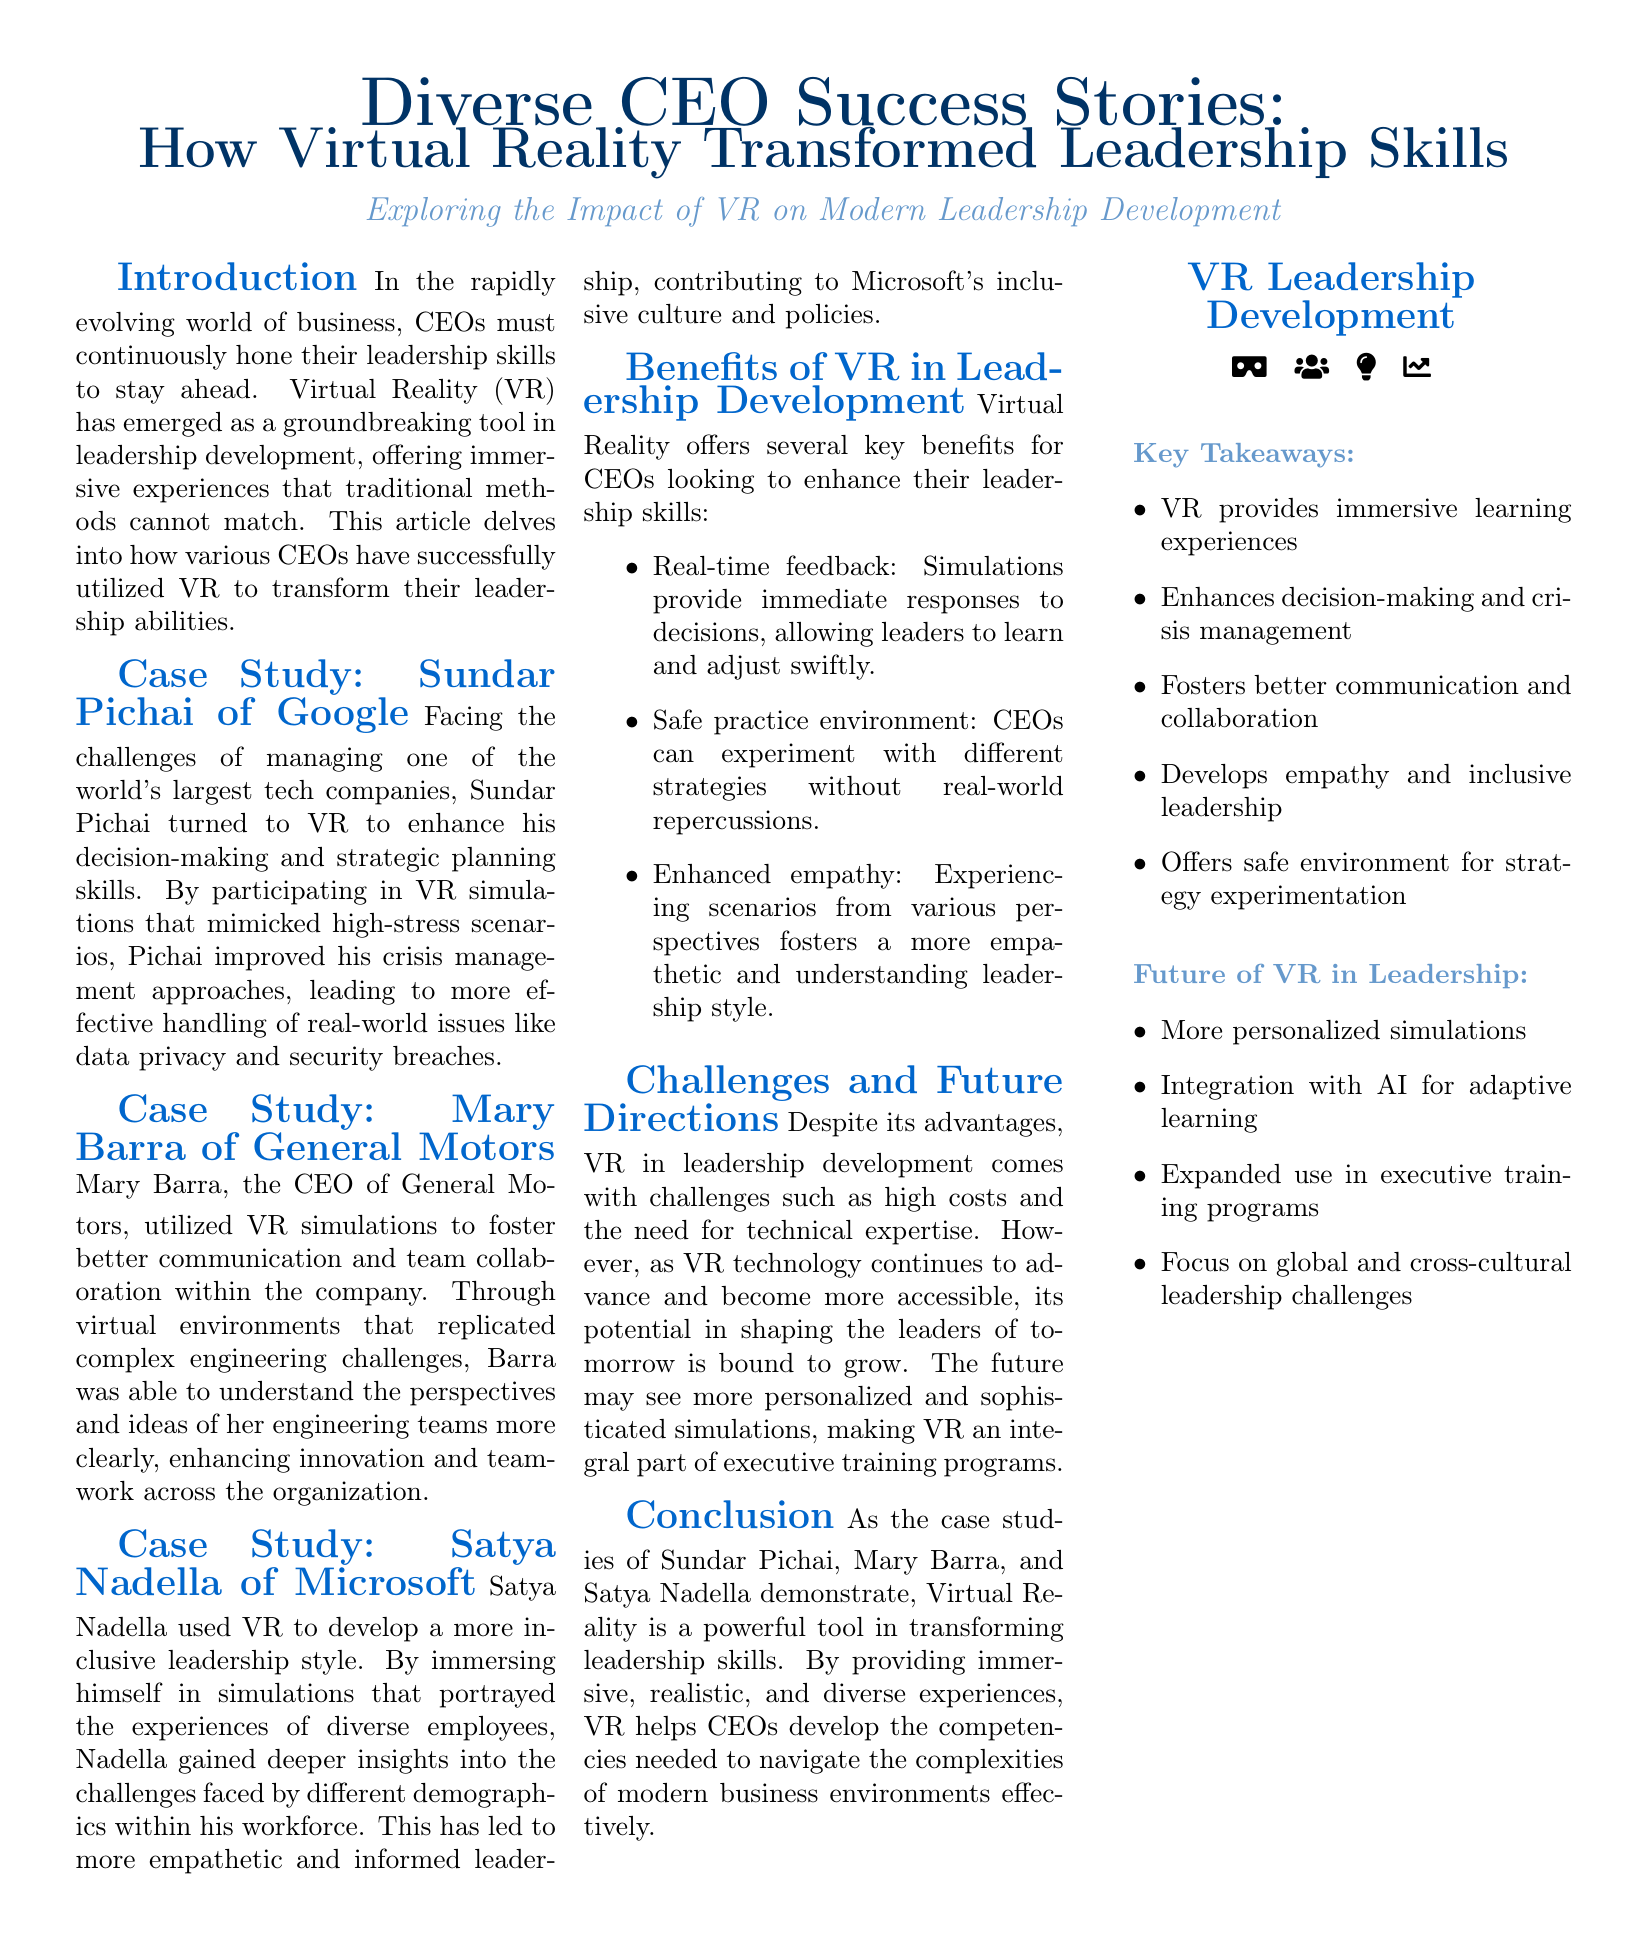What is the main topic of the article? The main topic of the article is the impact of Virtual Reality on leadership development among diverse CEOs.
Answer: Diverse CEO Success Stories Who is the CEO of General Motors mentioned in the document? The document specifically names Mary Barra as the CEO of General Motors.
Answer: Mary Barra What skill did Sundar Pichai enhance using VR? Sundar Pichai utilized VR to improve his decision-making and strategic planning skills.
Answer: Decision-making and strategic planning What perspective did Satya Nadella gain from VR simulations? Satya Nadella gained insights into the challenges faced by different demographics within his workforce.
Answer: Challenges faced by different demographics What key benefit of VR in leadership development is mentioned regarding practice environments? The document states that VR provides a safe practice environment for CEOs to experiment with strategies.
Answer: Safe practice environment What challenge of using VR technology in leadership is highlighted? The document mentions high costs as one of the challenges of using VR in leadership development.
Answer: High costs How many CEOs are highlighted in the case studies? The document references three CEOs in the case studies showcasing their success with VR.
Answer: Three What future direction does the document suggest for VR in leadership? The document suggests integrating AI for adaptive learning as a future direction for VR in leadership.
Answer: Integration with AI for adaptive learning 